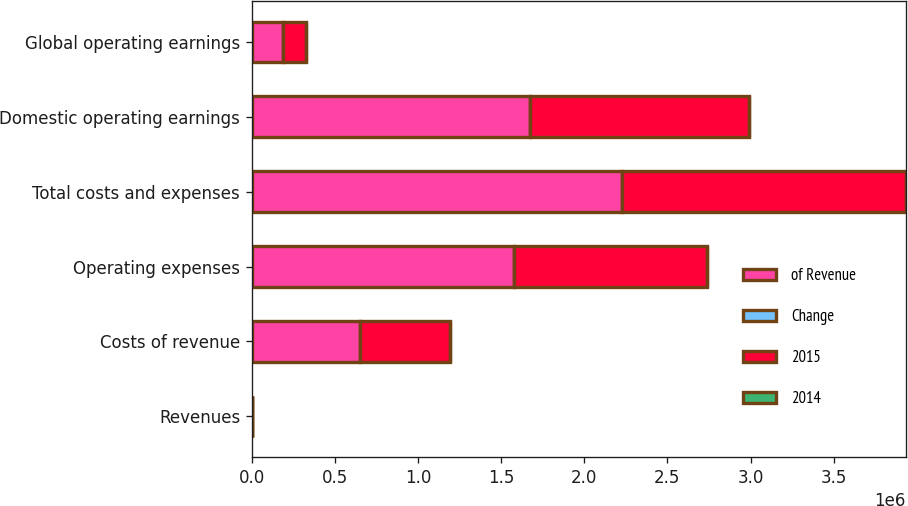Convert chart. <chart><loc_0><loc_0><loc_500><loc_500><stacked_bar_chart><ecel><fcel>Revenues<fcel>Costs of revenue<fcel>Operating expenses<fcel>Total costs and expenses<fcel>Domestic operating earnings<fcel>Global operating earnings<nl><fcel>of Revenue<fcel>78.5<fcel>651826<fcel>1.57759e+06<fcel>2.22942e+06<fcel>1.67503e+06<fcel>188811<nl><fcel>Change<fcel>100<fcel>17<fcel>40<fcel>57<fcel>43<fcel>36<nl><fcel>2015<fcel>78.5<fcel>542210<fcel>1.16341e+06<fcel>1.70562e+06<fcel>1.31617e+06<fcel>135781<nl><fcel>2014<fcel>29<fcel>20<fcel>36<fcel>31<fcel>27<fcel>39<nl></chart> 